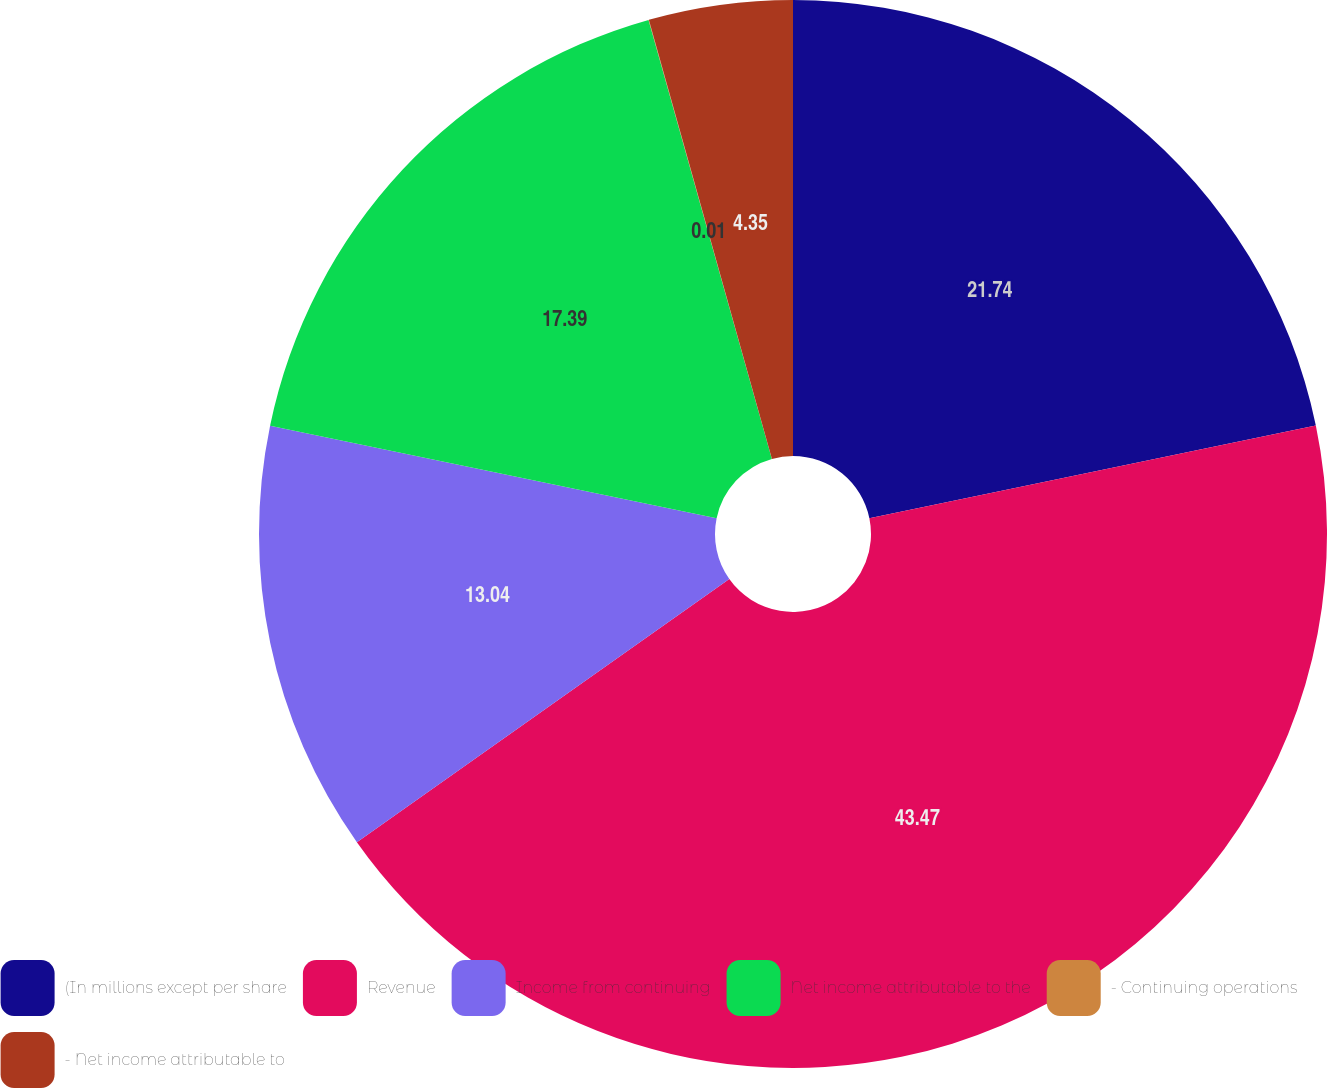Convert chart to OTSL. <chart><loc_0><loc_0><loc_500><loc_500><pie_chart><fcel>(In millions except per share<fcel>Revenue<fcel>Income from continuing<fcel>Net income attributable to the<fcel>- Continuing operations<fcel>- Net income attributable to<nl><fcel>21.74%<fcel>43.47%<fcel>13.04%<fcel>17.39%<fcel>0.01%<fcel>4.35%<nl></chart> 